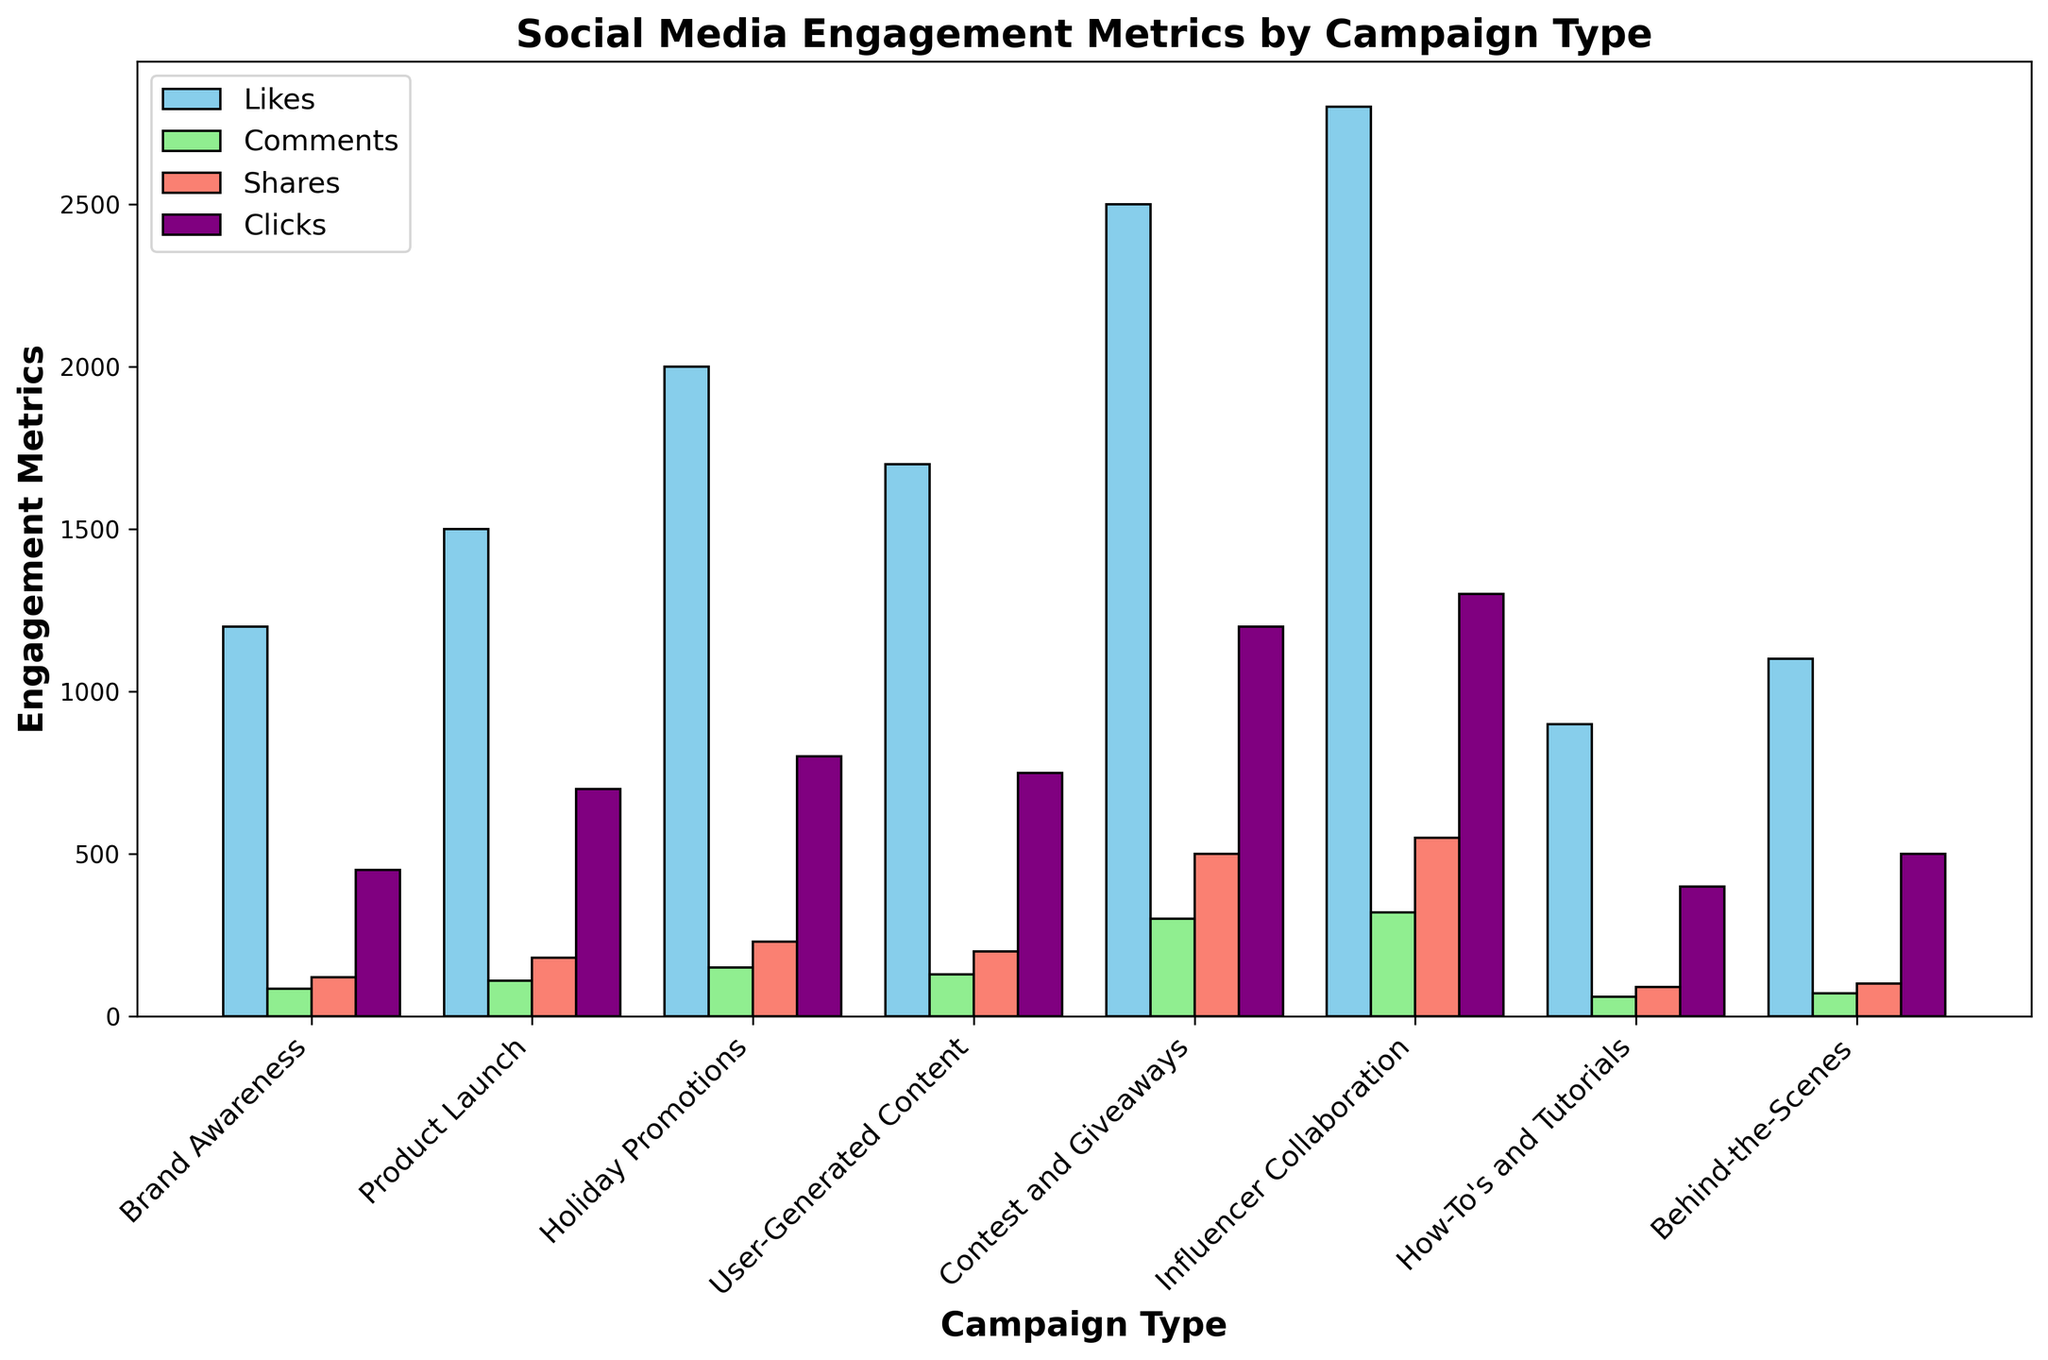What campaign type received the most likes? The bar representing "Influencer Collaboration" is the tallest in the "Likes" category, with a height surpassing all other bars in that category.
Answer: Influencer Collaboration Which campaign type received the least clicks? The "How-To's and Tutorials" bar is the shortest in the "Clicks" category, indicating it received the fewest clicks.
Answer: How-To's and Tutorials Which two campaign types have the closest number of comments? The heights of the bars for "User-Generated Content" and "Holiday Promotions" in the "Comments" category are very close to each other.
Answer: User-Generated Content and Holiday Promotions What is the combined total of shares for 'User-Generated Content' and 'Contest and Giveaways'? 'User-Generated Content' has 200 shares and 'Contest and Giveaways' has 500 shares. Adding these together gives 200 + 500 = 700.
Answer: 700 How do the likes for "Brand Awareness" compare to the likes for "Behind-the-Scenes"? The bar for "Brand Awareness" in the "Likes" category is taller than the bar for "Behind-the-Scenes", indicating more likes.
Answer: Brand Awareness has more likes than Behind-the-Scenes What is the difference in the number of clicks between "Product Launch" and "Influencer Collaboration"? The bar for "Product Launch" has 700 clicks, and the bar for "Influencer Collaboration" has 1300 clicks. The difference is 1300 - 700 = 600 clicks.
Answer: 600 What is the sum of likes for "Product Launch" and "Brand Awareness"? 'Product Launch' has 1500 likes and 'Brand Awareness' has 1200 likes. Their sum is 1500 + 1200 = 2700.
Answer: 2700 Which campaign type has the second lowest number of comments? The heights of the bars in the "Comments" category show that "How-To's and Tutorials" has the lowest number, and "Behind-the-Scenes" has the second lowest.
Answer: Behind-the-Scenes Which campaign types received more than 1000 clicks? The "Clicks" category shows bars for "Contest and Giveaways" and "Influencer Collaboration" extending beyond the 1000 mark, indicating these campaign types received over 1000 clicks.
Answer: Contest and Giveaways, Influencer Collaboration 